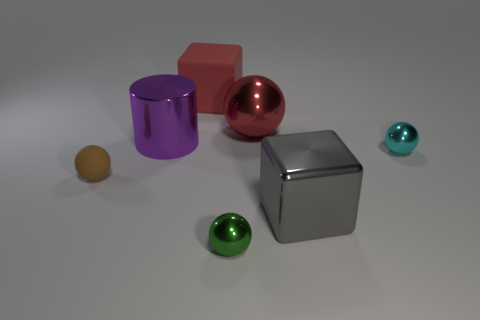Is there a gray metal cube of the same size as the green metallic ball?
Offer a very short reply. No. There is a tiny green ball that is in front of the small metallic object to the right of the big object that is in front of the small cyan shiny sphere; what is it made of?
Your response must be concise. Metal. There is a large block in front of the big red metallic object; what number of tiny metal objects are on the right side of it?
Keep it short and to the point. 1. There is a matte thing in front of the purple metal cylinder; is it the same size as the cyan object?
Your answer should be compact. Yes. What number of small brown matte things have the same shape as the cyan metallic thing?
Give a very brief answer. 1. The big matte object has what shape?
Ensure brevity in your answer.  Cube. Is the number of big metallic cylinders that are to the right of the large gray block the same as the number of red balls?
Your response must be concise. No. Are the cube that is behind the red shiny object and the red sphere made of the same material?
Ensure brevity in your answer.  No. Is the number of cyan metallic balls on the left side of the large cylinder less than the number of red cubes?
Provide a succinct answer. Yes. How many matte things are either purple cylinders or cubes?
Provide a succinct answer. 1. 